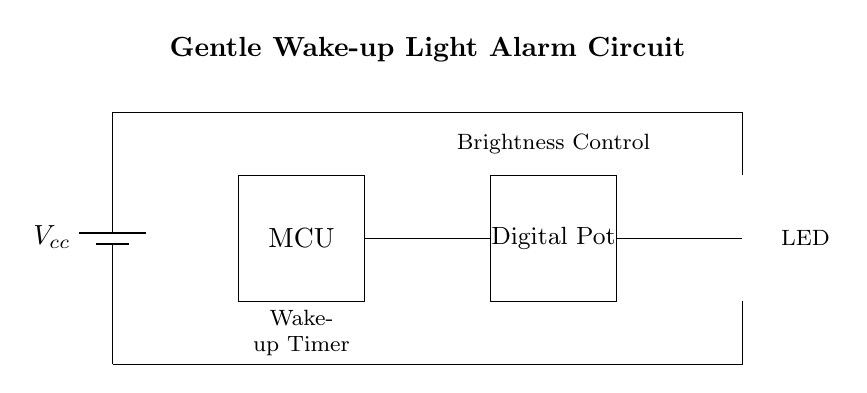What is the main component controlling the brightness? The component responsible for adjusting the brightness in the circuit is the digital potentiometer, which can vary the resistance and thus control the current flowing to the LED.
Answer: Digital Pot What does Vcc represent in this circuit? Vcc represents the power supply voltage for the circuit, which is necessary for powering the microcontroller and LED. It is typically the voltage provided to the circuit to operate.
Answer: Power supply voltage How many main components are in the circuit? The circuit includes four main components: the battery, microcontroller, digital potentiometer, and LED. Each of these plays a vital role in the function of the wake-up light.
Answer: Four What is the purpose of the microcontroller? The microcontroller's purpose is to control the overall operation of the circuit, including timing the wake-up process and adjusting the brightness of the LED gradually.
Answer: Control What type of circuit is this? This circuit is a gentle wake-up light alarm circuit, designed to simulate sunrise by gradually increasing the light brightness, which helps in waking up gently.
Answer: Alarm circuit 